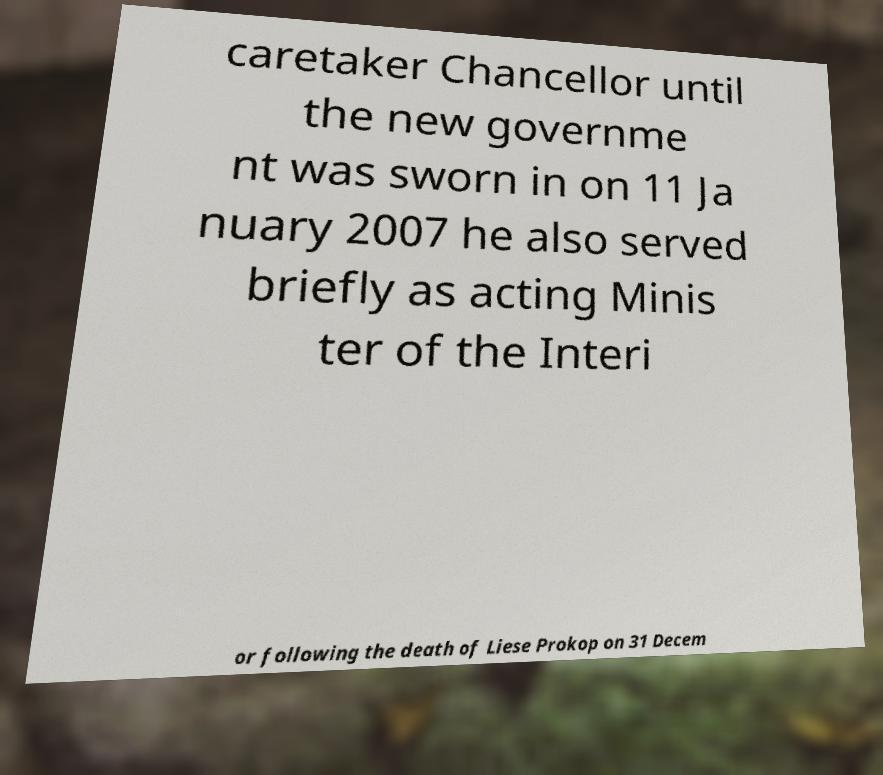There's text embedded in this image that I need extracted. Can you transcribe it verbatim? caretaker Chancellor until the new governme nt was sworn in on 11 Ja nuary 2007 he also served briefly as acting Minis ter of the Interi or following the death of Liese Prokop on 31 Decem 